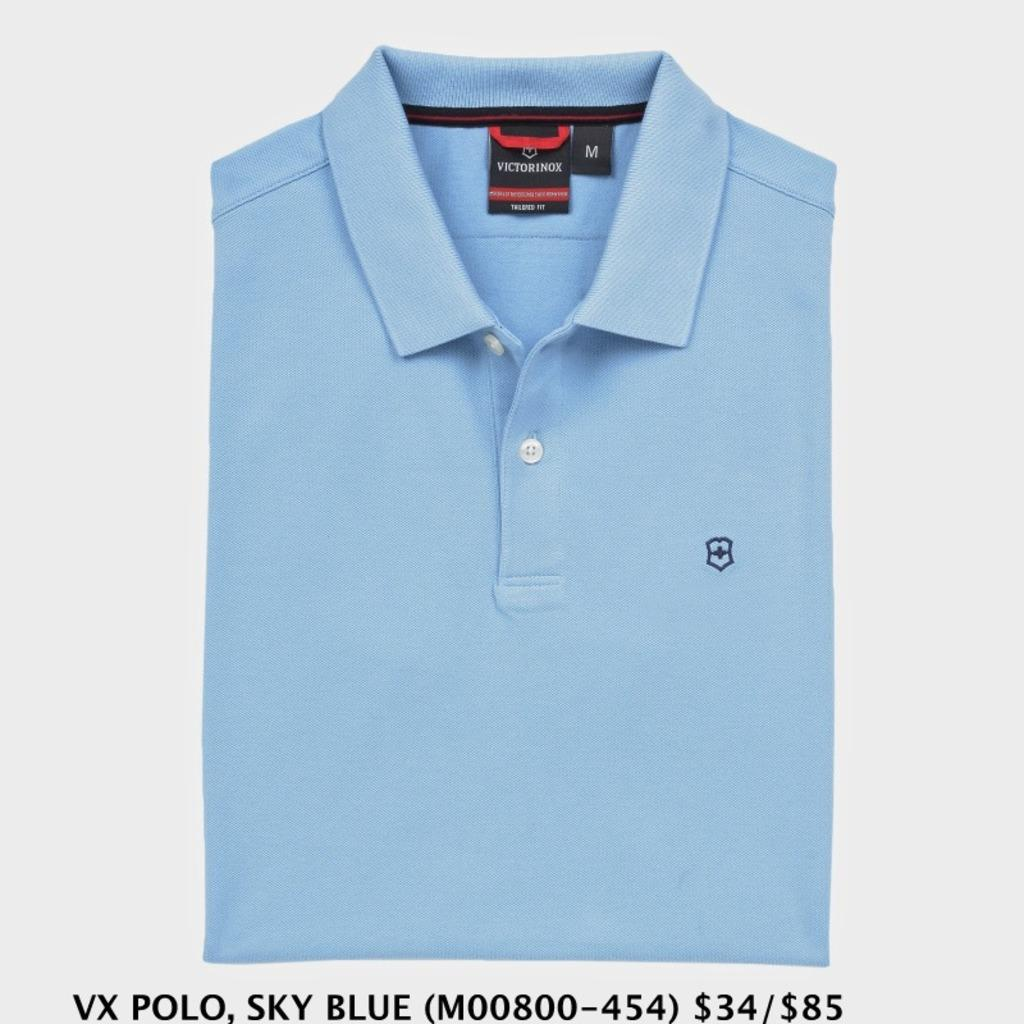<image>
Create a compact narrative representing the image presented. A sky blue medium sized Victorinox polo shirt. 